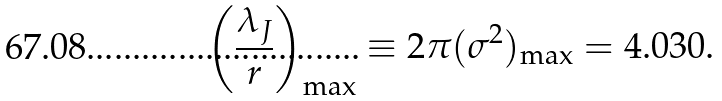Convert formula to latex. <formula><loc_0><loc_0><loc_500><loc_500>\left ( \frac { \lambda _ { J } } { r } \right ) _ { \max } \equiv 2 \pi ( \sigma ^ { 2 } ) _ { \max } = 4 . 0 3 0 .</formula> 